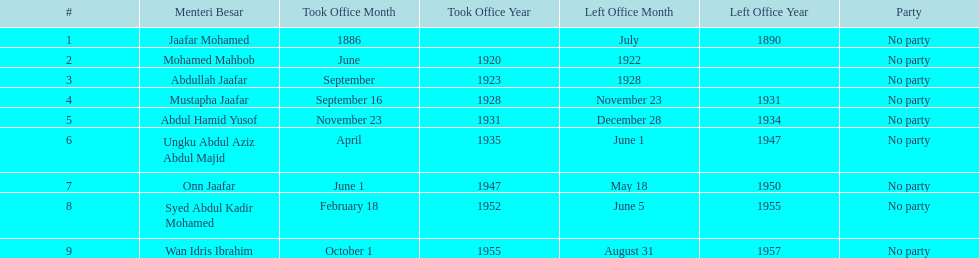Who was the first to take office? Jaafar Mohamed. 